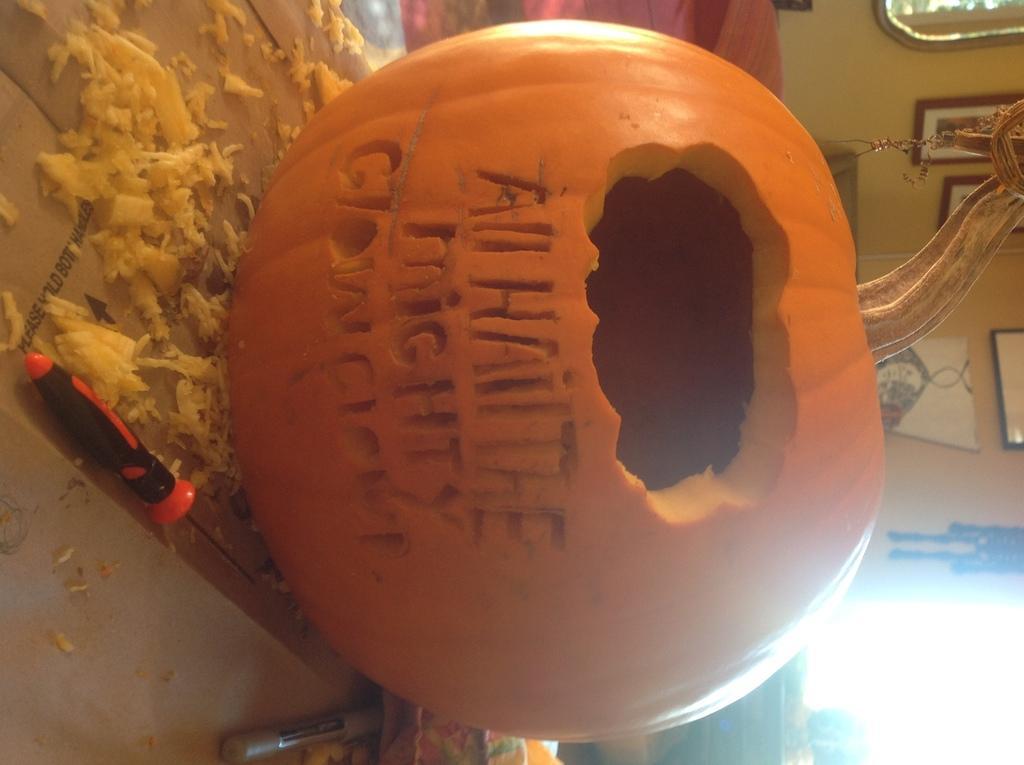Could you give a brief overview of what you see in this image? In this image I can see the pumpkin and I can see the tool and some objects. These are on the surface. In the background I can see many frames to the wall. 